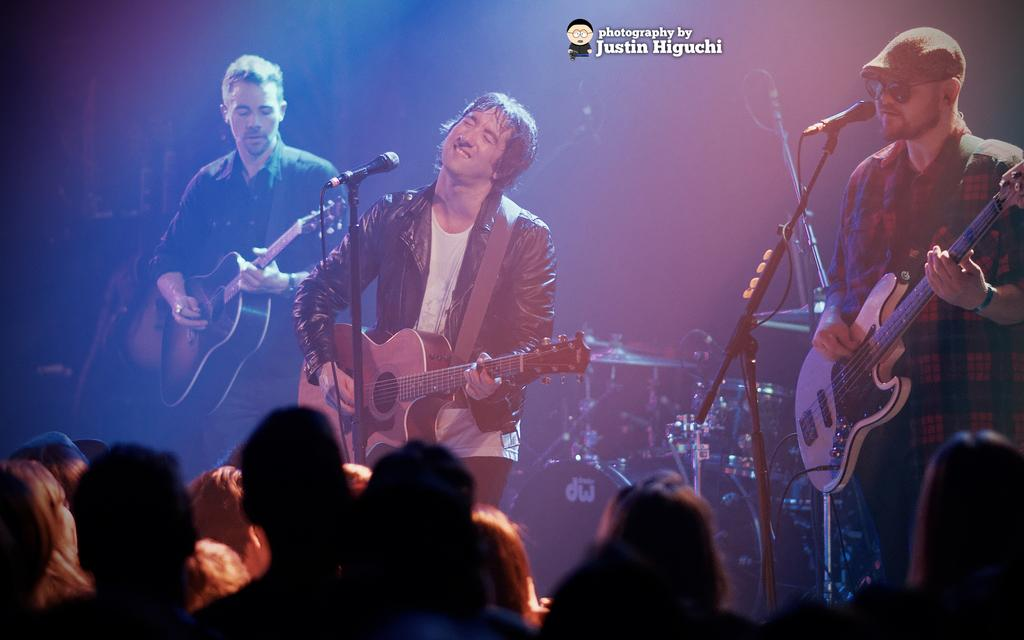What are the people on stage doing in the image? The three people standing on stage are each holding a guitar. What might the people on stage be using to amplify their voices? There is a microphone in front of the people on stage, which they might use to amplify their voices. Are there any other people visible in the image? Yes, there are additional people present in the image. What type of bread can be seen on the stage in the image? There is no bread present on the stage in the image. Is there any gold visible in the image? There is no gold visible in the image. 